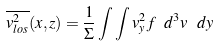<formula> <loc_0><loc_0><loc_500><loc_500>\overline { v ^ { 2 } _ { l o s } } ( x , z ) = \frac { 1 } { \Sigma } \int \int v ^ { 2 } _ { y } f \ d ^ { 3 } v \ d y</formula> 